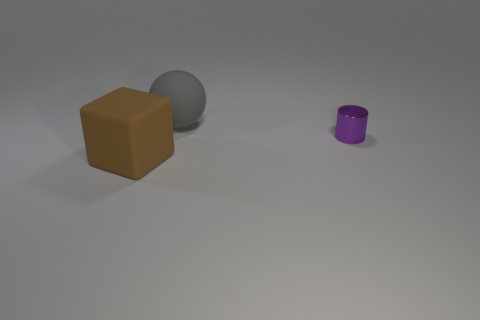Add 3 big gray objects. How many objects exist? 6 Subtract all blocks. How many objects are left? 2 Subtract 0 yellow blocks. How many objects are left? 3 Subtract all green blocks. Subtract all large things. How many objects are left? 1 Add 3 gray rubber spheres. How many gray rubber spheres are left? 4 Add 1 rubber things. How many rubber things exist? 3 